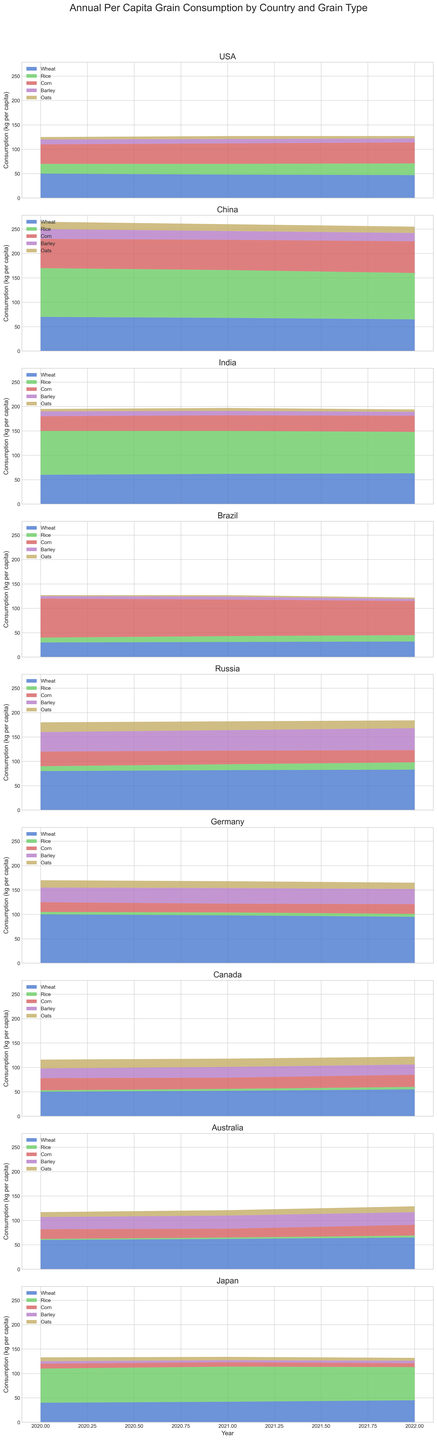What is the trend of wheat consumption in the USA over the years 2020-2022? The USA's wheat consumption decreases slightly each year from 50 kg per capita in 2020 to 47 kg per capita in 2022.
Answer: Decreasing Which grain type saw the largest increase in per capita consumption in China between 2020 and 2022? In China, corn consumption increased from 60 kg per capita in 2020 to 65 kg per capita in 2022. All other grain types either decreased or increased less significantly.
Answer: Corn Compare the total grain consumption in Brazil between 2020 and 2022. To find the total, add the values of all grain types for each year. For 2020: 30 + 10 + 80 + 5 + 2 = 127 kg. For 2022: 32 + 13 + 70 + 4 + 3 = 122 kg. The total decreased from 127 kg to 122 kg.
Answer: Decreased In which country was rice the dominant grain type in 2022? By visually inspecting the charts, rice has the highest consumption in China for 2022 with 95 kg per capita, compared to other grains in the same country.
Answer: China What visual trend do you see in Japan's barley and oat consumption from 2020 to 2022? In Japan, barley consumption remains constant at around 5 kg per capita, while oats consumption decreases slightly from 8 kg per capita in 2020 to 6 kg in 2022.
Answer: Barley constant, Oats decreasing Which two countries show increasing trends in oats consumption from 2020 to 2022? By examining the charts, Canada and Australia show increasing trends. Canada increases from 18 kg to 16 kg, while Australia increases from 10 kg to 12 kg.
Answer: Canada, Australia How does Germany's wheat consumption in 2022 compare to Russia's wheat consumption in the same year? Looking closely, Germany's wheat consumption in 2022 is 95 kg per capita, while Russia's is 83 kg per capita. Germany's wheat consumption is higher than Russia's.
Answer: Germany's higher What is the average per capita barley consumption in India across the years 2020-2022? To find the average, add the barley consumption values and divide by the number of years. (10 + 9 + 8) / 3 = 27 / 3 = 9 kg per capita.
Answer: 9 kg per capita Which country had the lowest corn consumption in 2021? Based on the visual inspection, Japan had the lowest corn consumption in 2021 with 9 kg per capita.
Answer: Japan 